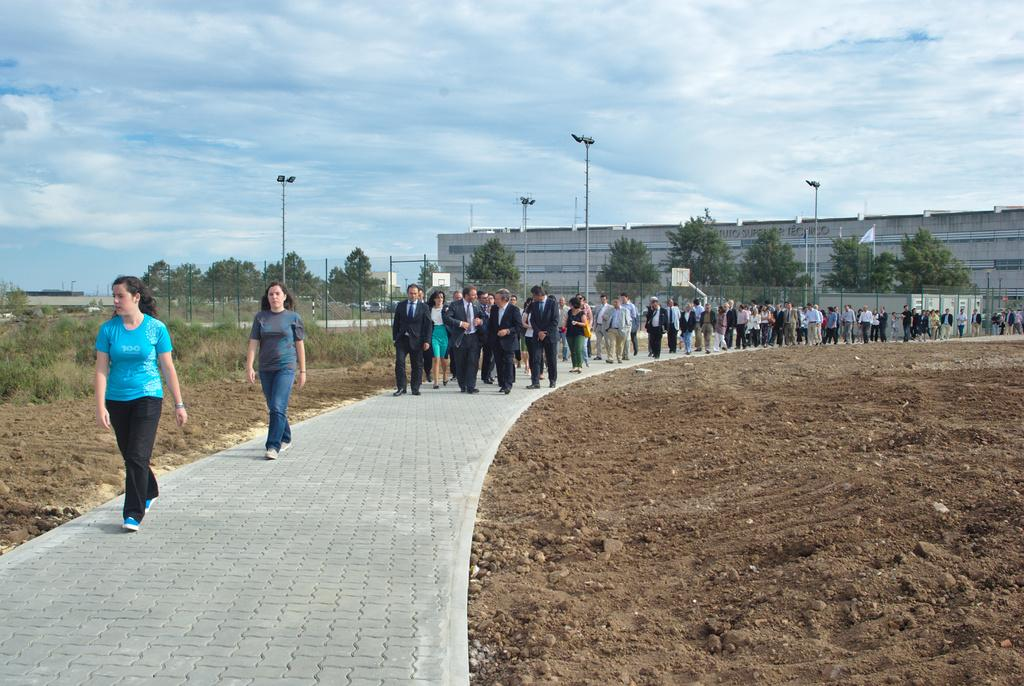What are the people in the image doing? The people in the image are walking. What can be seen in the background of the image? In the background of the image, there are trees, poles, buildings, posters, and the sky. Can you describe the environment in the image? The environment in the image includes people walking and various structures and objects in the background, such as trees, poles, buildings, posters, and the sky. What type of waste is being collected in the bucket in the image? There is no bucket or waste present in the image. What company is responsible for the posters in the image? The image does not provide information about the company responsible for the posters. 